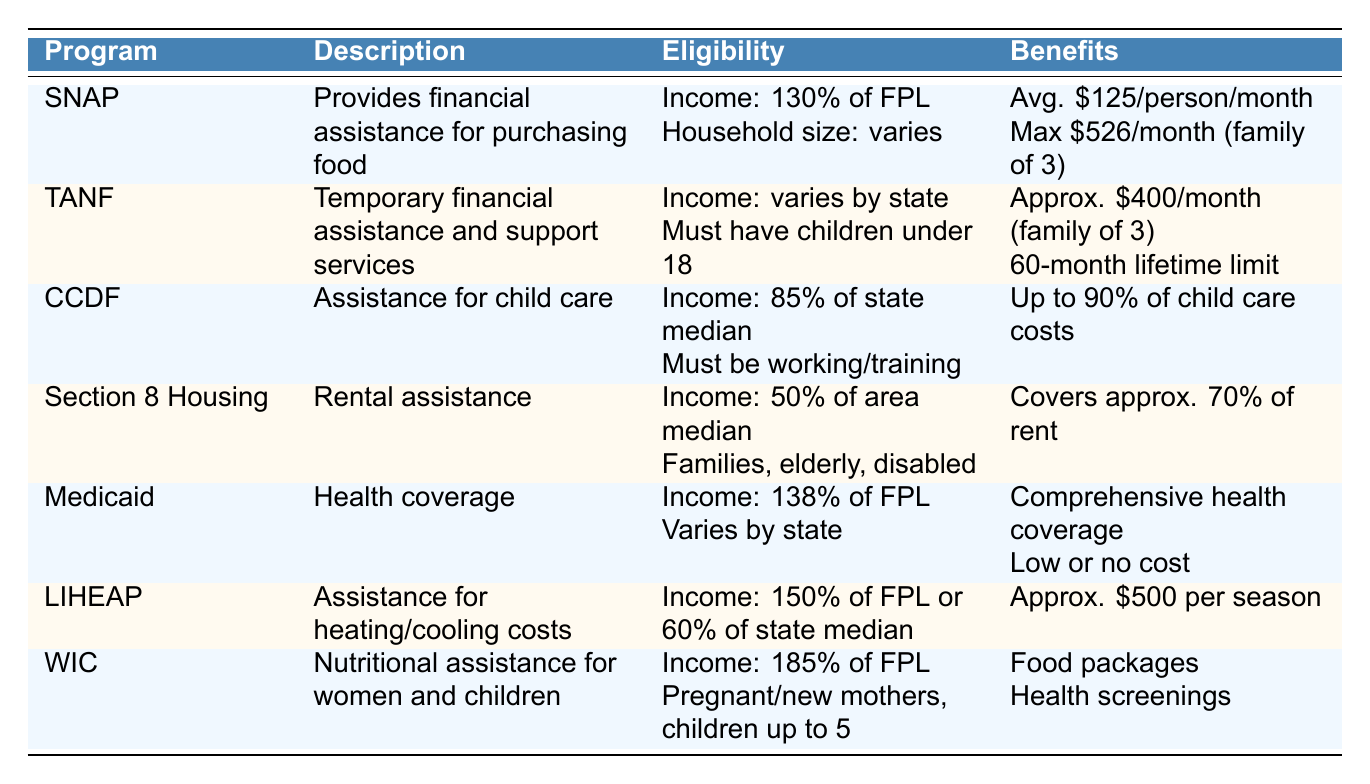What is the average benefit per person per month for the SNAP program? The table lists the average benefit per person per month for the SNAP program as "$125".
Answer: $125 What is the maximum benefit for a family of three in the SNAP program? The table indicates that the maximum benefit for a family of three in the SNAP program is "$526".
Answer: $526 Is there a lifetime limit for receiving TANF benefits? According to the table, TANF has a lifetime limit of "60 months (5 years)", which confirms that there is a limit.
Answer: Yes Does the Section 8 Housing program assist only families? The eligibility criteria for the Section 8 Housing program includes families, the elderly, and the disabled, which means it does not assist only families.
Answer: No What is the income limit for eligibility under the Medicaid program? The table specifies that the income limit for the Medicaid program is "138% of the FPL".
Answer: 138% of the FPL If a family qualifies for both SNAP and WIC, what types of support would they receive? The family would receive food assistance from SNAP (average $125 per person) and nutritious food packages plus health screenings from WIC, which are tailored to pregnant women, breastfeeding mothers, and children up to age 5. This indicates comprehensive support for food and health.
Answer: Food assistance and health screenings What is the total approximate cash assistance for a family of three under both TANF and LIHEAP programs? TANF provides approximately "$400" per month, and LIHEAP offers "$500" approximately per heating/cooling season (let's assume this is annual for simplicity). Thus, the total cash assistance would be $400 multiplied by 12 for TANF ($4,800) plus $500 for LIHEAP, making a total of $4,800 + $500 = $5,300.
Answer: $5,300 What percentage of child care costs does the CCDF assist with? The table states that CCDF provides subsidies "up to 90% of child care costs". Therefore, it assists with 90%.
Answer: 90% Is it true that the LIHEAP program assists households above 150% of the FPL? The table specifies that the income limit for LIHEAP is "150% of the FPL or 60% of the state median income". This indicates the program assists households at or below this income level, therefore it is false that it assists above.
Answer: No 